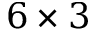Convert formula to latex. <formula><loc_0><loc_0><loc_500><loc_500>6 \times 3</formula> 